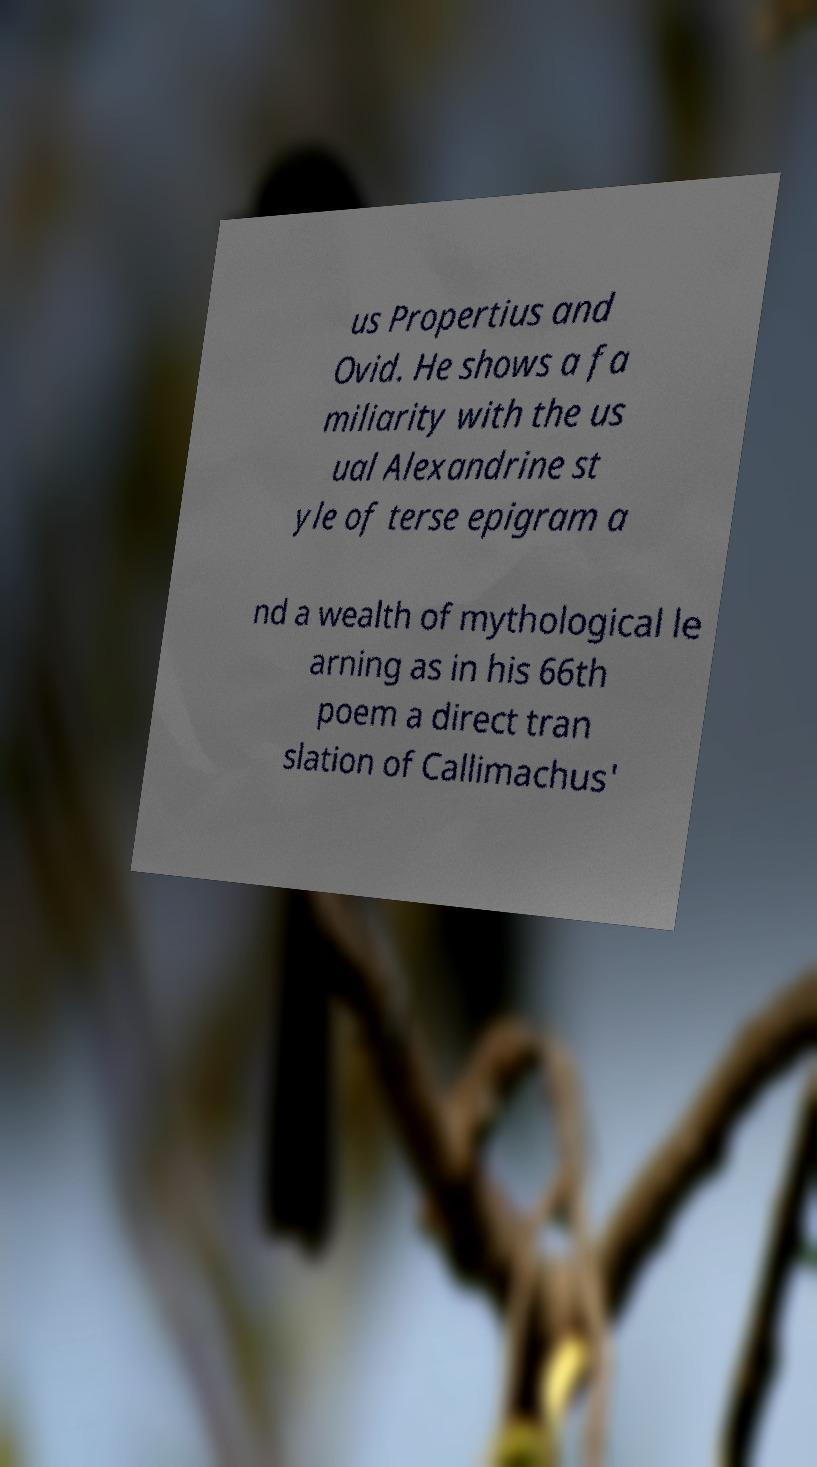Can you accurately transcribe the text from the provided image for me? us Propertius and Ovid. He shows a fa miliarity with the us ual Alexandrine st yle of terse epigram a nd a wealth of mythological le arning as in his 66th poem a direct tran slation of Callimachus' 